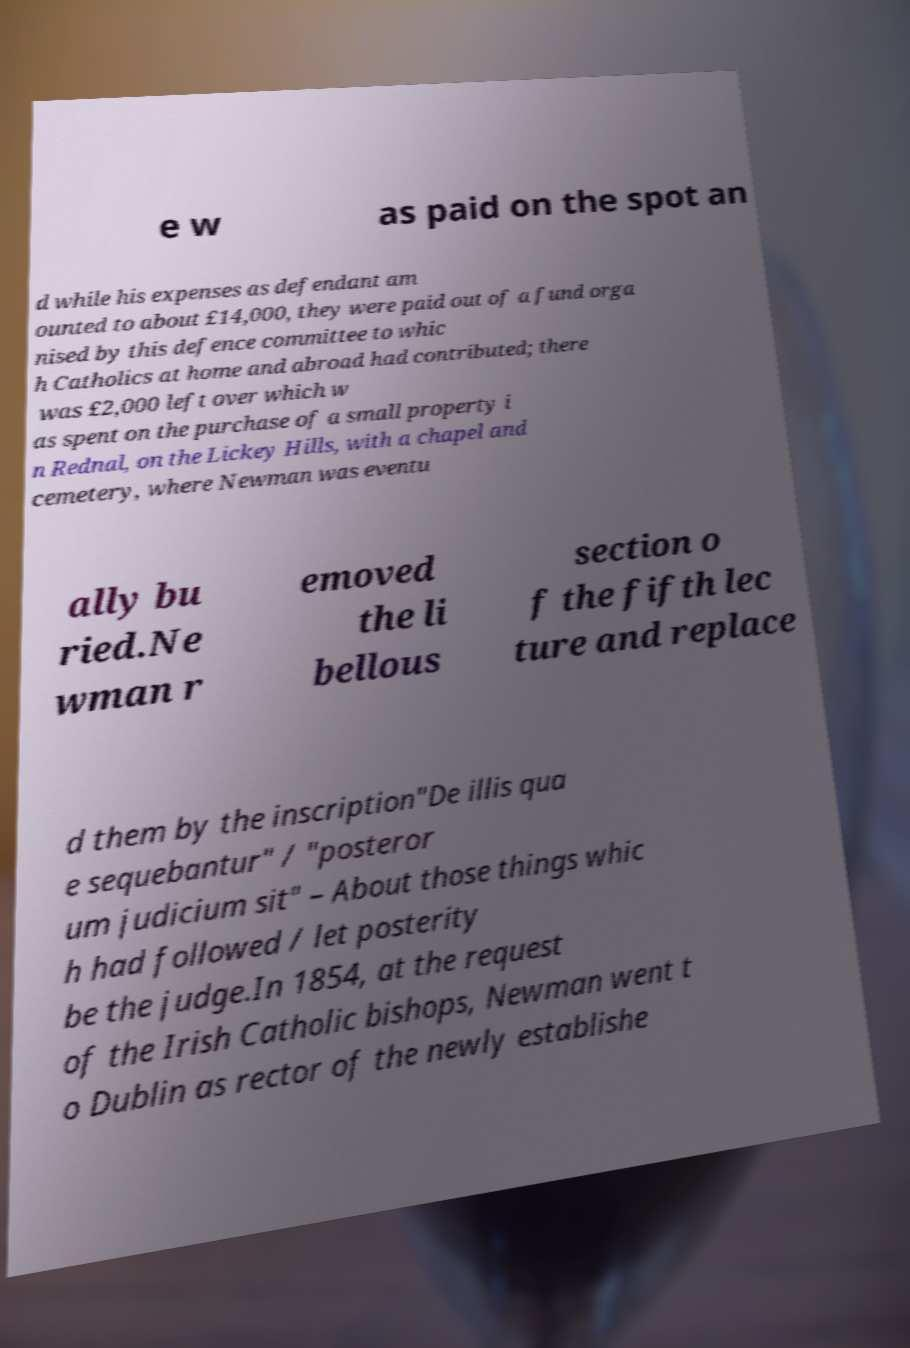There's text embedded in this image that I need extracted. Can you transcribe it verbatim? e w as paid on the spot an d while his expenses as defendant am ounted to about £14,000, they were paid out of a fund orga nised by this defence committee to whic h Catholics at home and abroad had contributed; there was £2,000 left over which w as spent on the purchase of a small property i n Rednal, on the Lickey Hills, with a chapel and cemetery, where Newman was eventu ally bu ried.Ne wman r emoved the li bellous section o f the fifth lec ture and replace d them by the inscription"De illis qua e sequebantur" / "posteror um judicium sit" – About those things whic h had followed / let posterity be the judge.In 1854, at the request of the Irish Catholic bishops, Newman went t o Dublin as rector of the newly establishe 